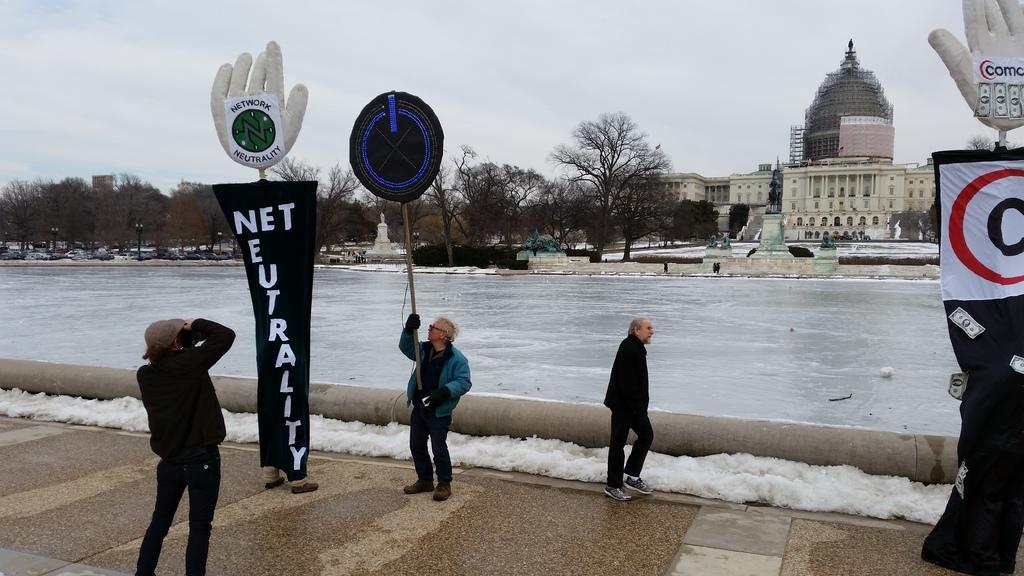What does that sign say?
Offer a very short reply. Net neutrality. 